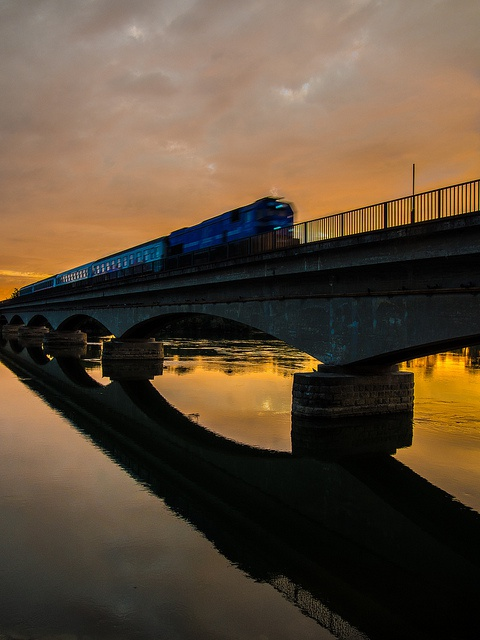Describe the objects in this image and their specific colors. I can see a train in gray, black, navy, blue, and orange tones in this image. 